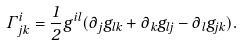<formula> <loc_0><loc_0><loc_500><loc_500>\Gamma ^ { i } _ { j k } = \frac { 1 } { 2 } g ^ { i l } ( \partial _ { j } g _ { l k } + \partial _ { k } g _ { l j } - \partial _ { l } g _ { j k } ) .</formula> 